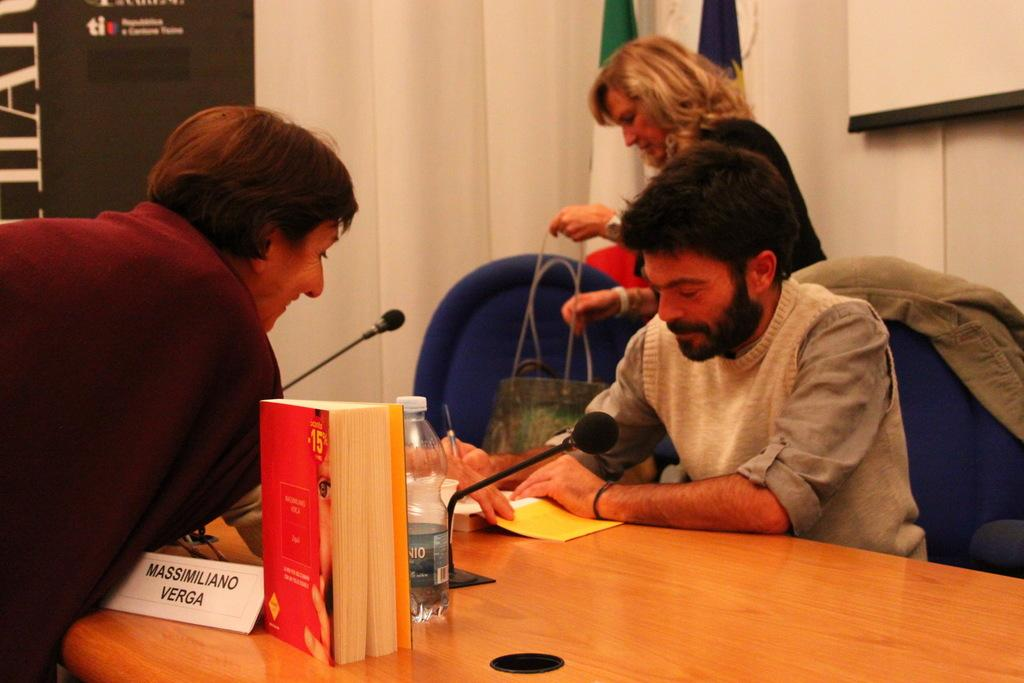<image>
Present a compact description of the photo's key features. Two people leaning over opposite sides of a desk with the words Massimilano Verga in front of one 